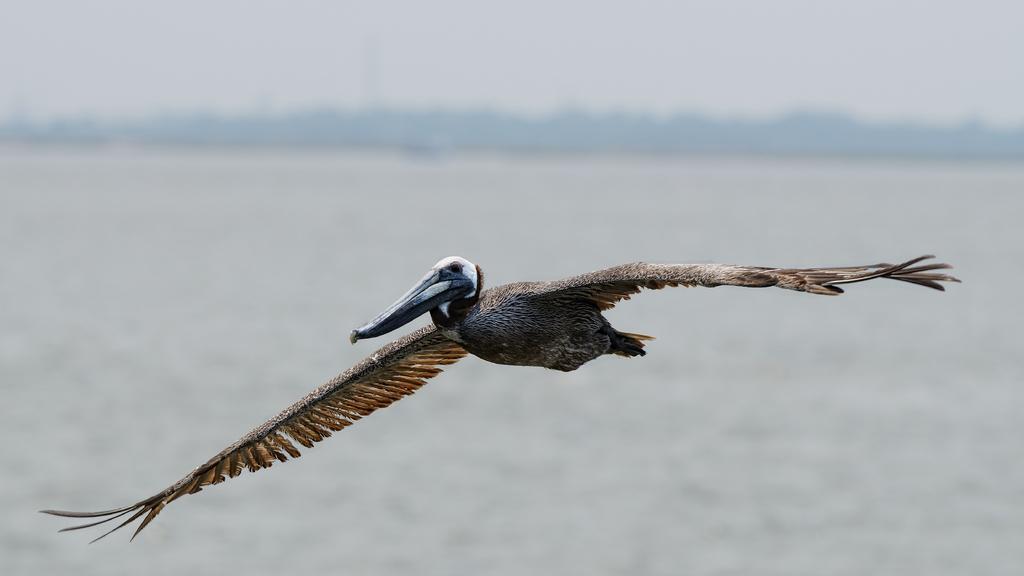Please provide a concise description of this image. In this image, we can see a bird flying and the background is not clear. 